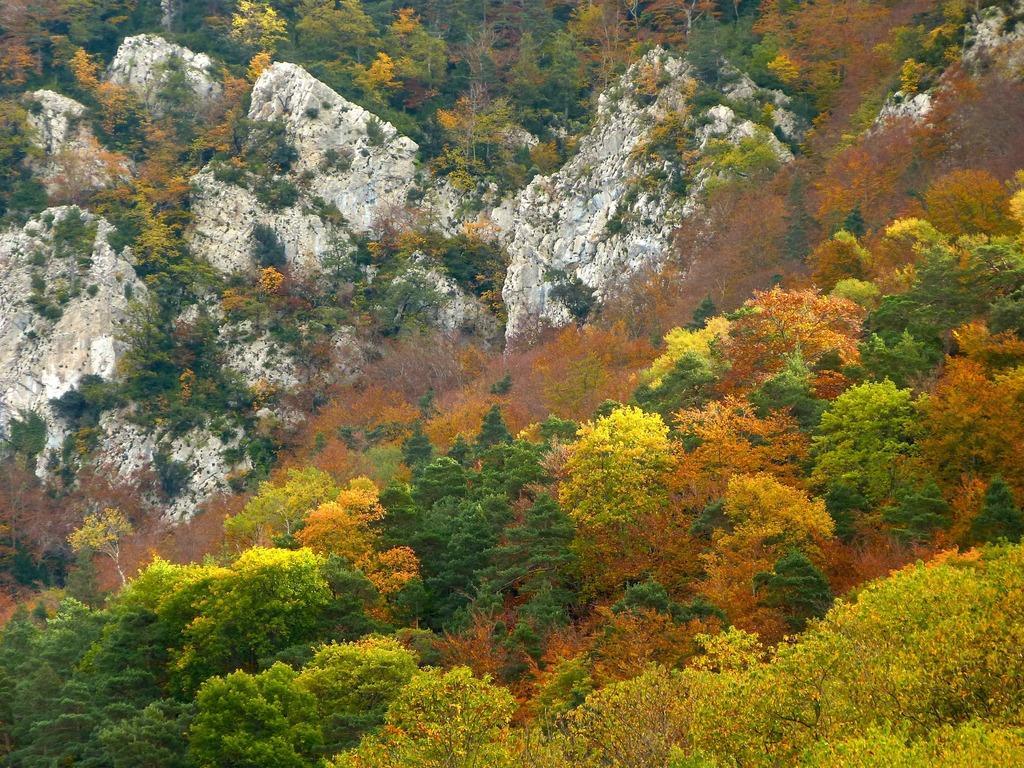Could you give a brief overview of what you see in this image? In this image I can see few trees in green, yellow and orange color. Background I can see few rocks. 